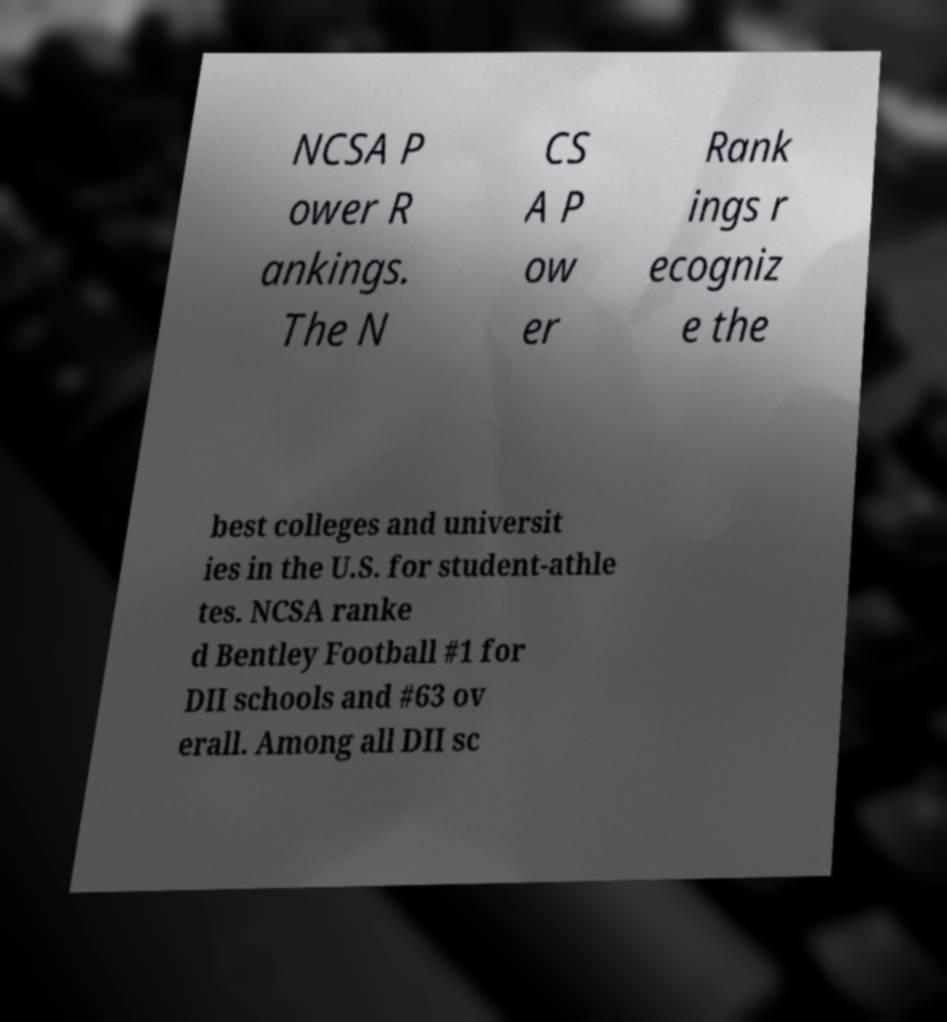There's text embedded in this image that I need extracted. Can you transcribe it verbatim? NCSA P ower R ankings. The N CS A P ow er Rank ings r ecogniz e the best colleges and universit ies in the U.S. for student-athle tes. NCSA ranke d Bentley Football #1 for DII schools and #63 ov erall. Among all DII sc 